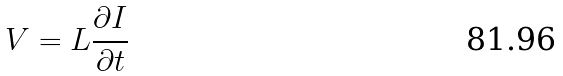Convert formula to latex. <formula><loc_0><loc_0><loc_500><loc_500>V = L \frac { \partial I } { \partial t }</formula> 